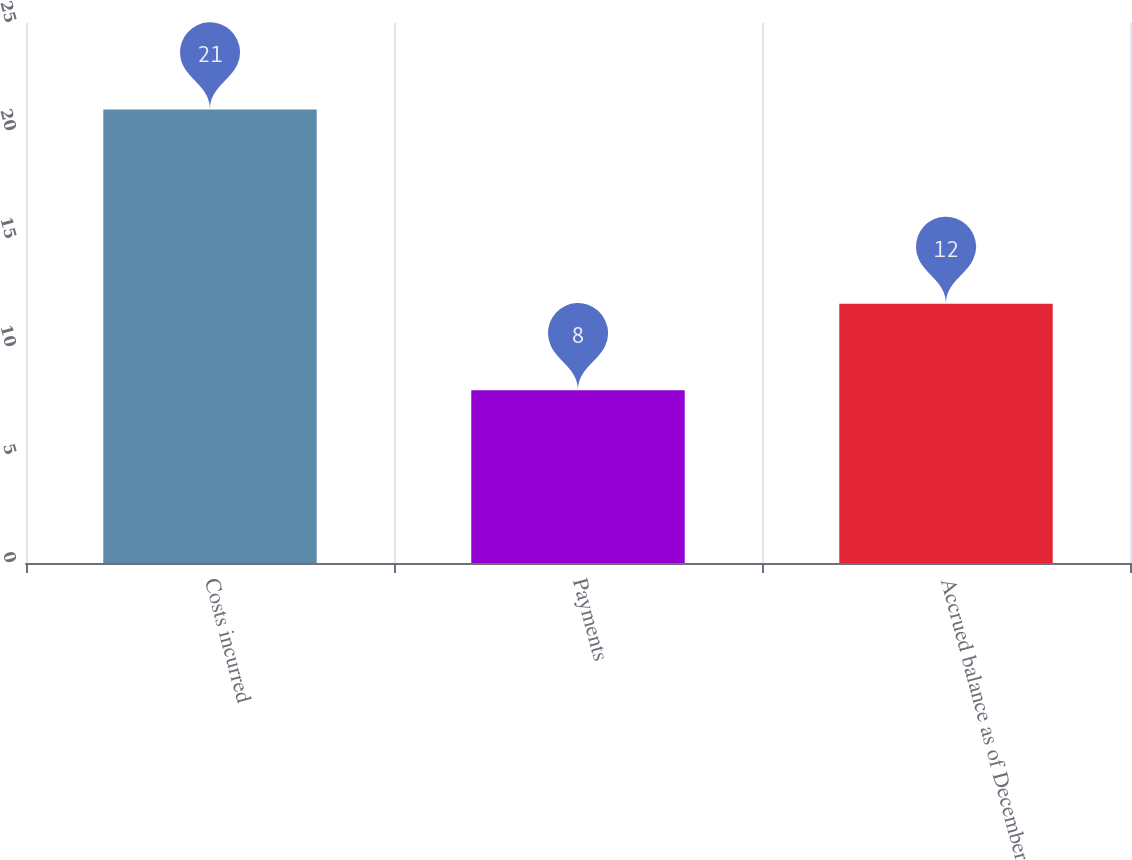<chart> <loc_0><loc_0><loc_500><loc_500><bar_chart><fcel>Costs incurred<fcel>Payments<fcel>Accrued balance as of December<nl><fcel>21<fcel>8<fcel>12<nl></chart> 